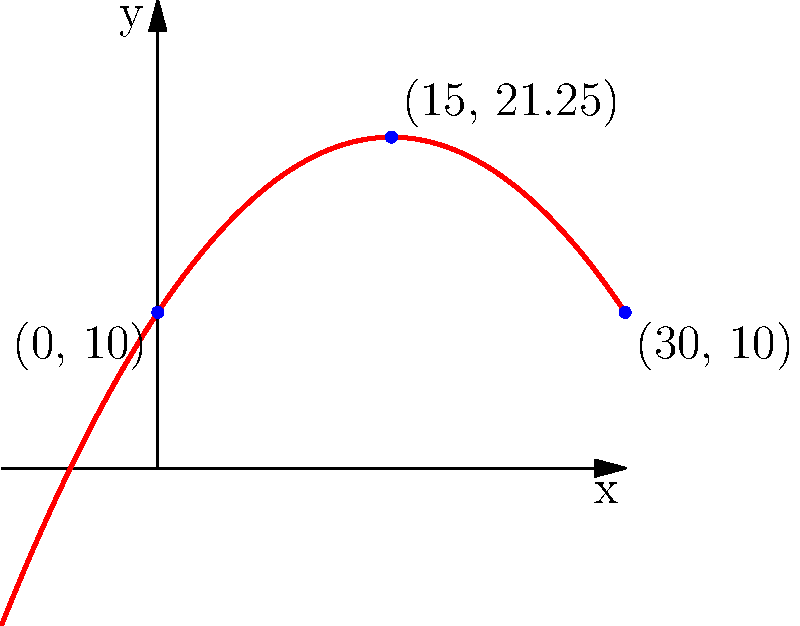Congratulations! You've been hired as the lead engineer for "Twisted Thrills Amusement Park." Your first task is to design a rollercoaster called "The Parabolic Plunge." The track needs to follow a parabolic path that starts at height 10 meters, reaches its peak at 21.25 meters when horizontally 15 meters from the start, and ends at 10 meters when horizontally 30 meters from the start. Find the equation of this rollercoaster track in the form $y = ax^2 + bx + c$, where $x$ is the horizontal distance and $y$ is the height. (Hint: This might be the most fun you've had with math since learning about asymptotes!) Let's dive into this twisted tale of parabolic proportions:

1) We know the general form of a parabola is $y = ax^2 + bx + c$.

2) We have three points on our parabola:
   (0, 10), (15, 21.25), and (30, 10)

3) Let's plug these into our equation:
   10 = a(0)^2 + b(0) + c
   21.25 = a(15)^2 + b(15) + c
   10 = a(30)^2 + b(30) + c

4) From the first equation:
   c = 10

5) Subtracting the first equation from the third:
   0 = 900a + 30b
   b = -30a

6) Now, let's plug these into the second equation:
   21.25 = a(15)^2 + (-30a)(15) + 10
   21.25 = 225a - 450a + 10
   11.25 = -225a
   a = -0.05

7) Now we can find b:
   b = -30(-0.05) = 1.5

Therefore, our equation is:
$y = -0.05x^2 + 1.5x + 10$

Congratulations! You've just designed a rollercoaster that will make your guests scream with delight (or terror, but who's keeping track?).
Answer: $y = -0.05x^2 + 1.5x + 10$ 